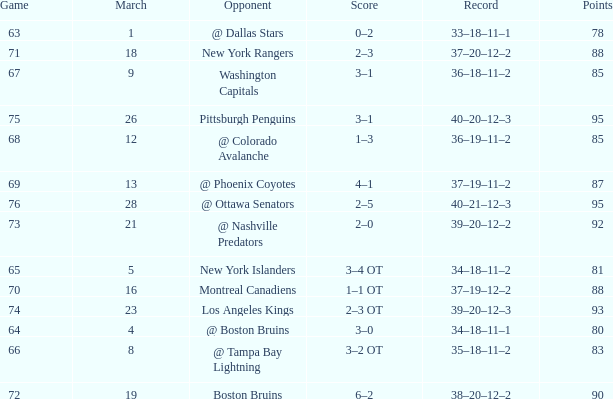How many Points have a Record of 40–21–12–3, and a March larger than 28? 0.0. 